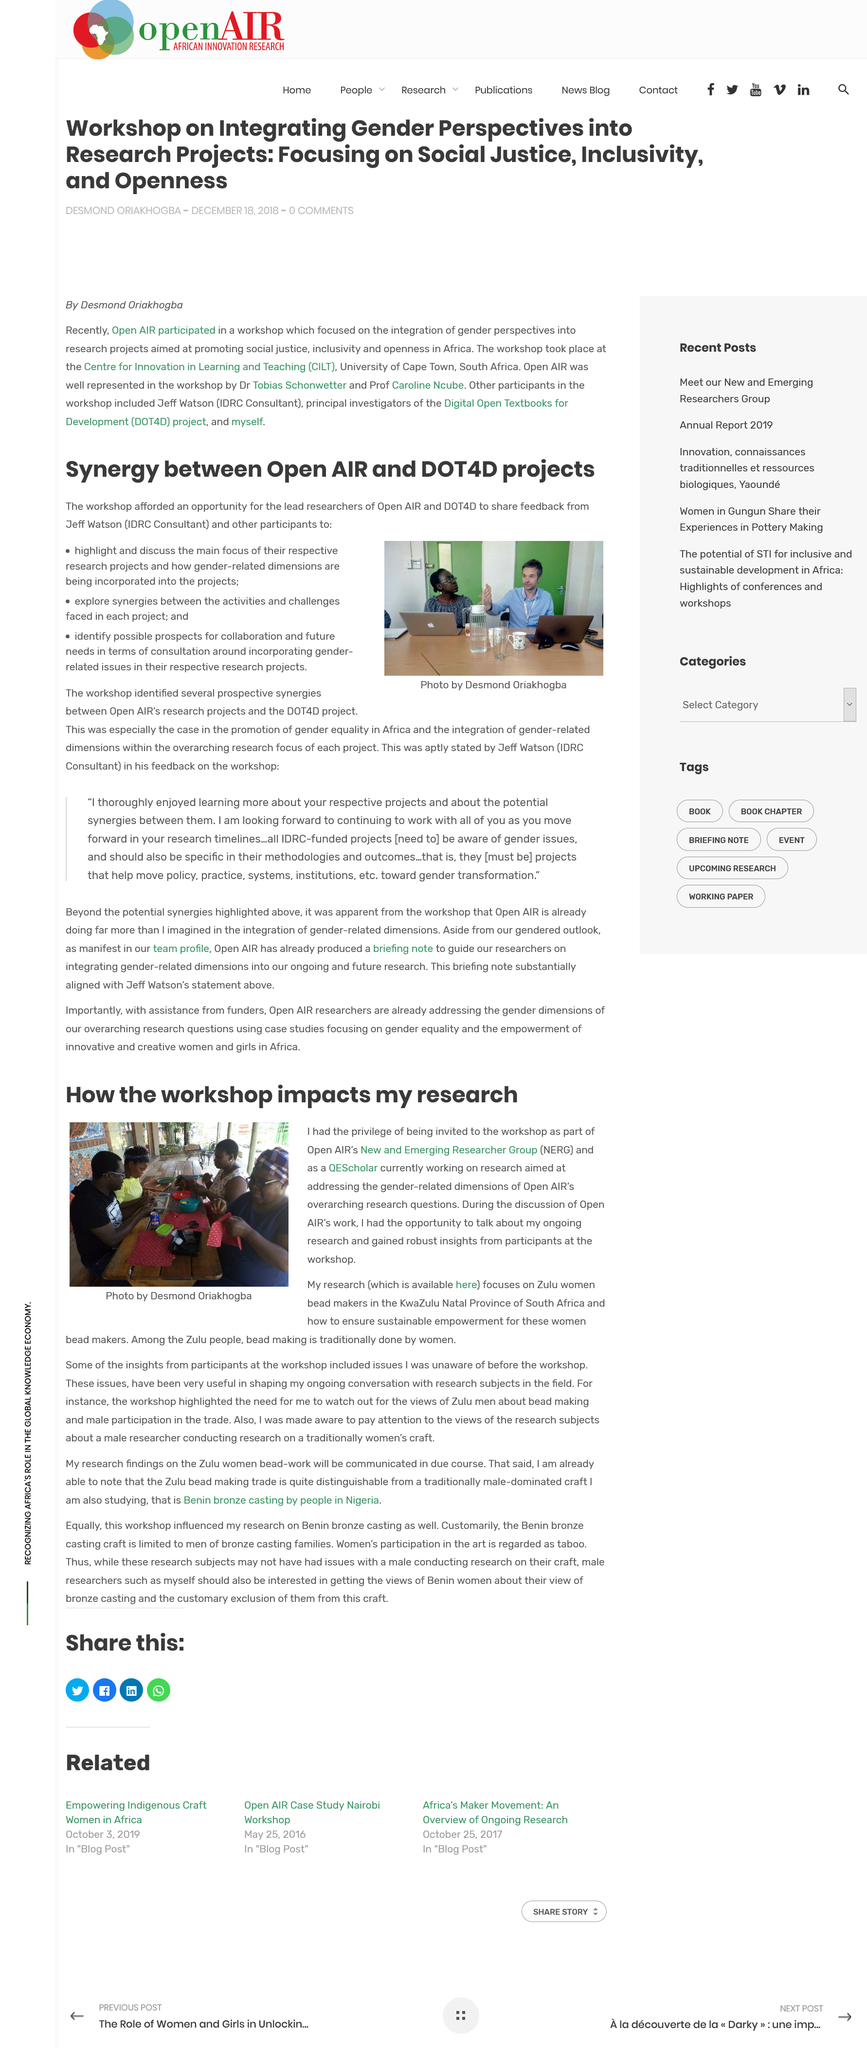Identify some key points in this picture. Research conducted by OpenAir's NERG is focused on addressing gender-related job opportunities and disparities. The author is currently involved in research on the sustainability of Zulu women bead makers, with a focus on their practices and methods. The traditional bead maker's gender is women. 